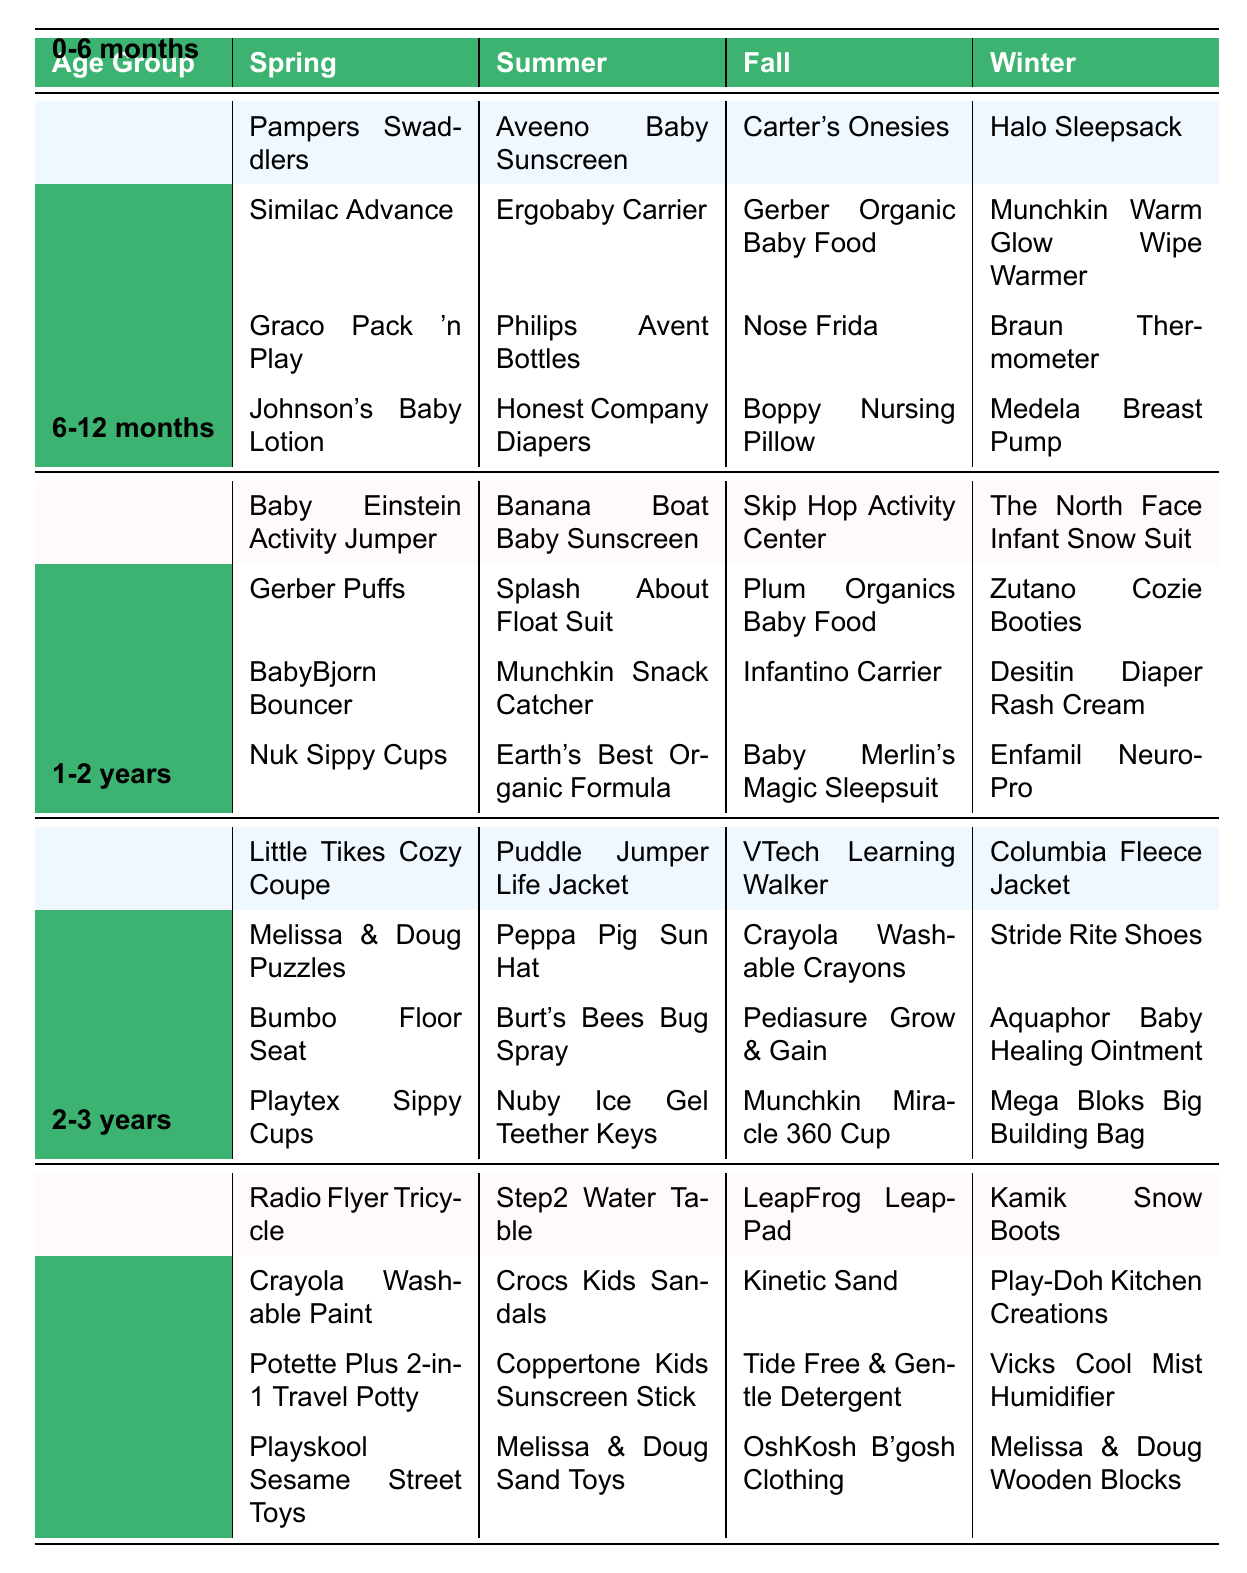What are the popular baby products for the age group 0-6 months during Winter? The table shows the products listed under the Winter column for the 0-6 months age group, which include Halo Sleepsack, Munchkin Warm Glow Wipe Warmer, Braun Thermometer, and Medela Breast Pump.
Answer: Halo Sleepsack, Munchkin Warm Glow Wipe Warmer, Braun Thermometer, Medela Breast Pump Which product is commonly used in Summer for the age group 1-2 years? Looking at the Summer column for the 1-2 years age group, the products listed are Puddle Jumper Life Jacket, Peppa Pig Sun Hat, Burt's Bees Bug Spray, and Nuby Ice Gel Teether Keys.
Answer: Puddle Jumper Life Jacket, Peppa Pig Sun Hat, Burt's Bees Bug Spray, Nuby Ice Gel Teether Keys Is there a product related to teething for babies aged 6-12 months? The table includes Nuby Ice Gel Teether Keys in the Summer column for the 1-2 years age group, which is a teething product that could be suitable for babies transitioning from 6-12 months.
Answer: Yes Which age group has the most products listed in the Fall season? The Fall column lists 4 products for each age group. There is no difference in quantity, but the products vary for each age group.
Answer: All age groups have an equal number of products What's the total number of different products listed for the age group 2-3 years in Spring and Winter combined? For the 2-3 years age group, the Spring column lists 4 products, and the Winter column also has 4 products, giving a total of 8 products combined.
Answer: 8 Are there any common products found in both the Summer and Fall columns for the age group 0-6 months? The Summer column has products specific to that season, and similarly, the Fall column lists different ones for 0-6 months. Comparing the two, there are no products that appear in both columns.
Answer: No How many products are listed for the age group 1-2 years during the Spring season? In the Spring column for the age group 1-2 years, there are 4 products listed: Little Tikes Cozy Coupe, Melissa & Doug Puzzles, Bumbo Floor Seat, and Playtex Sippy Cups.
Answer: 4 In the Winter, which age group has the product "Stride Rite Shoes"? The Winter column lists Stride Rite Shoes under the 1-2 years age group, as identified from the table’s data.
Answer: 1-2 years 